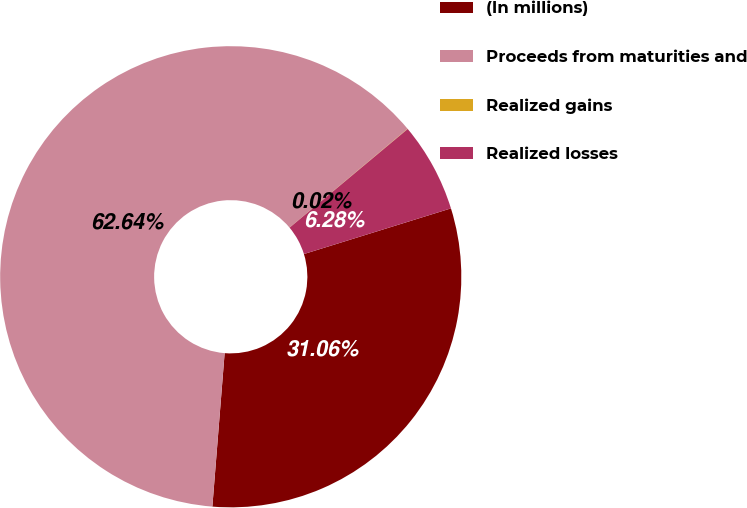Convert chart. <chart><loc_0><loc_0><loc_500><loc_500><pie_chart><fcel>(In millions)<fcel>Proceeds from maturities and<fcel>Realized gains<fcel>Realized losses<nl><fcel>31.06%<fcel>62.63%<fcel>0.02%<fcel>6.28%<nl></chart> 